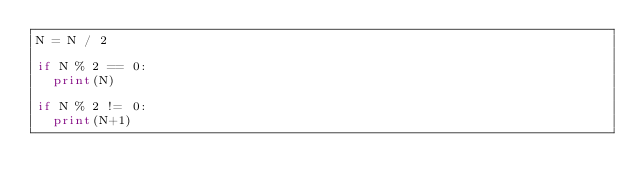<code> <loc_0><loc_0><loc_500><loc_500><_Python_>N = N / 2

if N % 2 == 0:
  print(N)
  
if N % 2 != 0:
  print(N+1)
  
</code> 